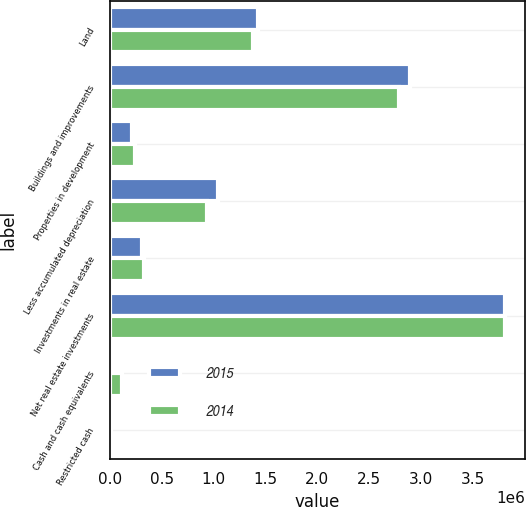<chart> <loc_0><loc_0><loc_500><loc_500><stacked_bar_chart><ecel><fcel>Land<fcel>Buildings and improvements<fcel>Properties in development<fcel>Less accumulated depreciation<fcel>Investments in real estate<fcel>Net real estate investments<fcel>Cash and cash equivalents<fcel>Restricted cash<nl><fcel>2015<fcel>1.43247e+06<fcel>2.8964e+06<fcel>217036<fcel>1.04379e+06<fcel>306206<fcel>3.80832e+06<fcel>36856<fcel>3767<nl><fcel>2014<fcel>1.38021e+06<fcel>2.79014e+06<fcel>239538<fcel>933708<fcel>333167<fcel>3.80934e+06<fcel>113776<fcel>8013<nl></chart> 